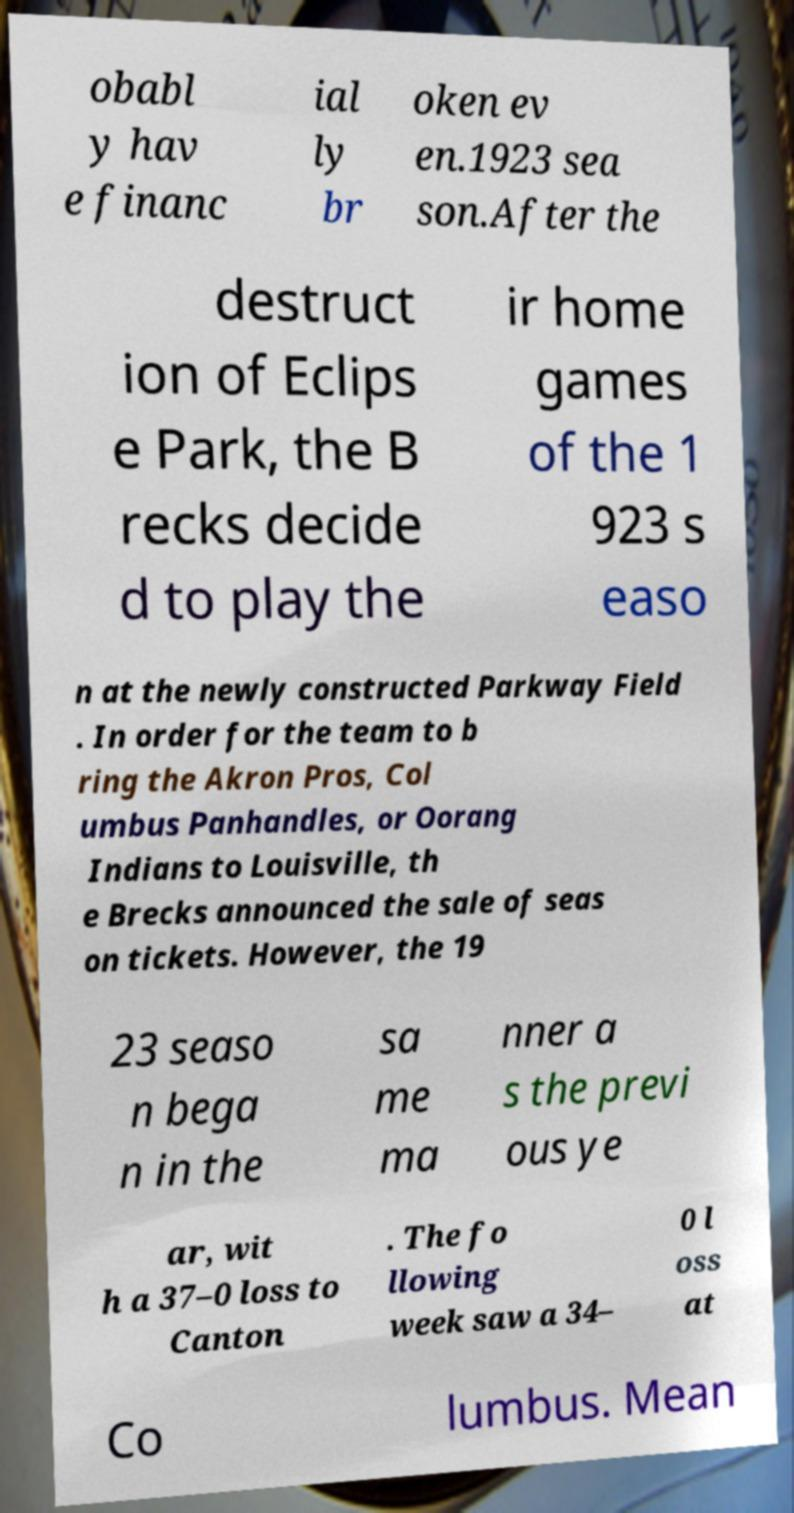Can you read and provide the text displayed in the image?This photo seems to have some interesting text. Can you extract and type it out for me? obabl y hav e financ ial ly br oken ev en.1923 sea son.After the destruct ion of Eclips e Park, the B recks decide d to play the ir home games of the 1 923 s easo n at the newly constructed Parkway Field . In order for the team to b ring the Akron Pros, Col umbus Panhandles, or Oorang Indians to Louisville, th e Brecks announced the sale of seas on tickets. However, the 19 23 seaso n bega n in the sa me ma nner a s the previ ous ye ar, wit h a 37–0 loss to Canton . The fo llowing week saw a 34– 0 l oss at Co lumbus. Mean 